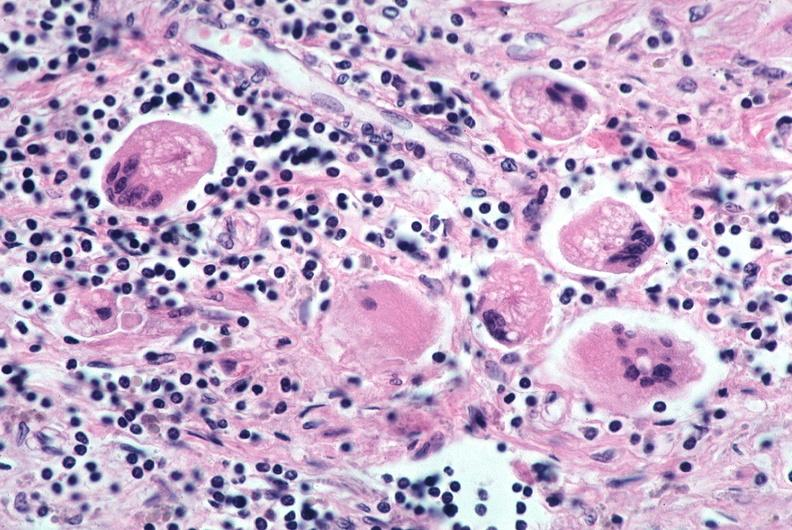s respiratory present?
Answer the question using a single word or phrase. Yes 